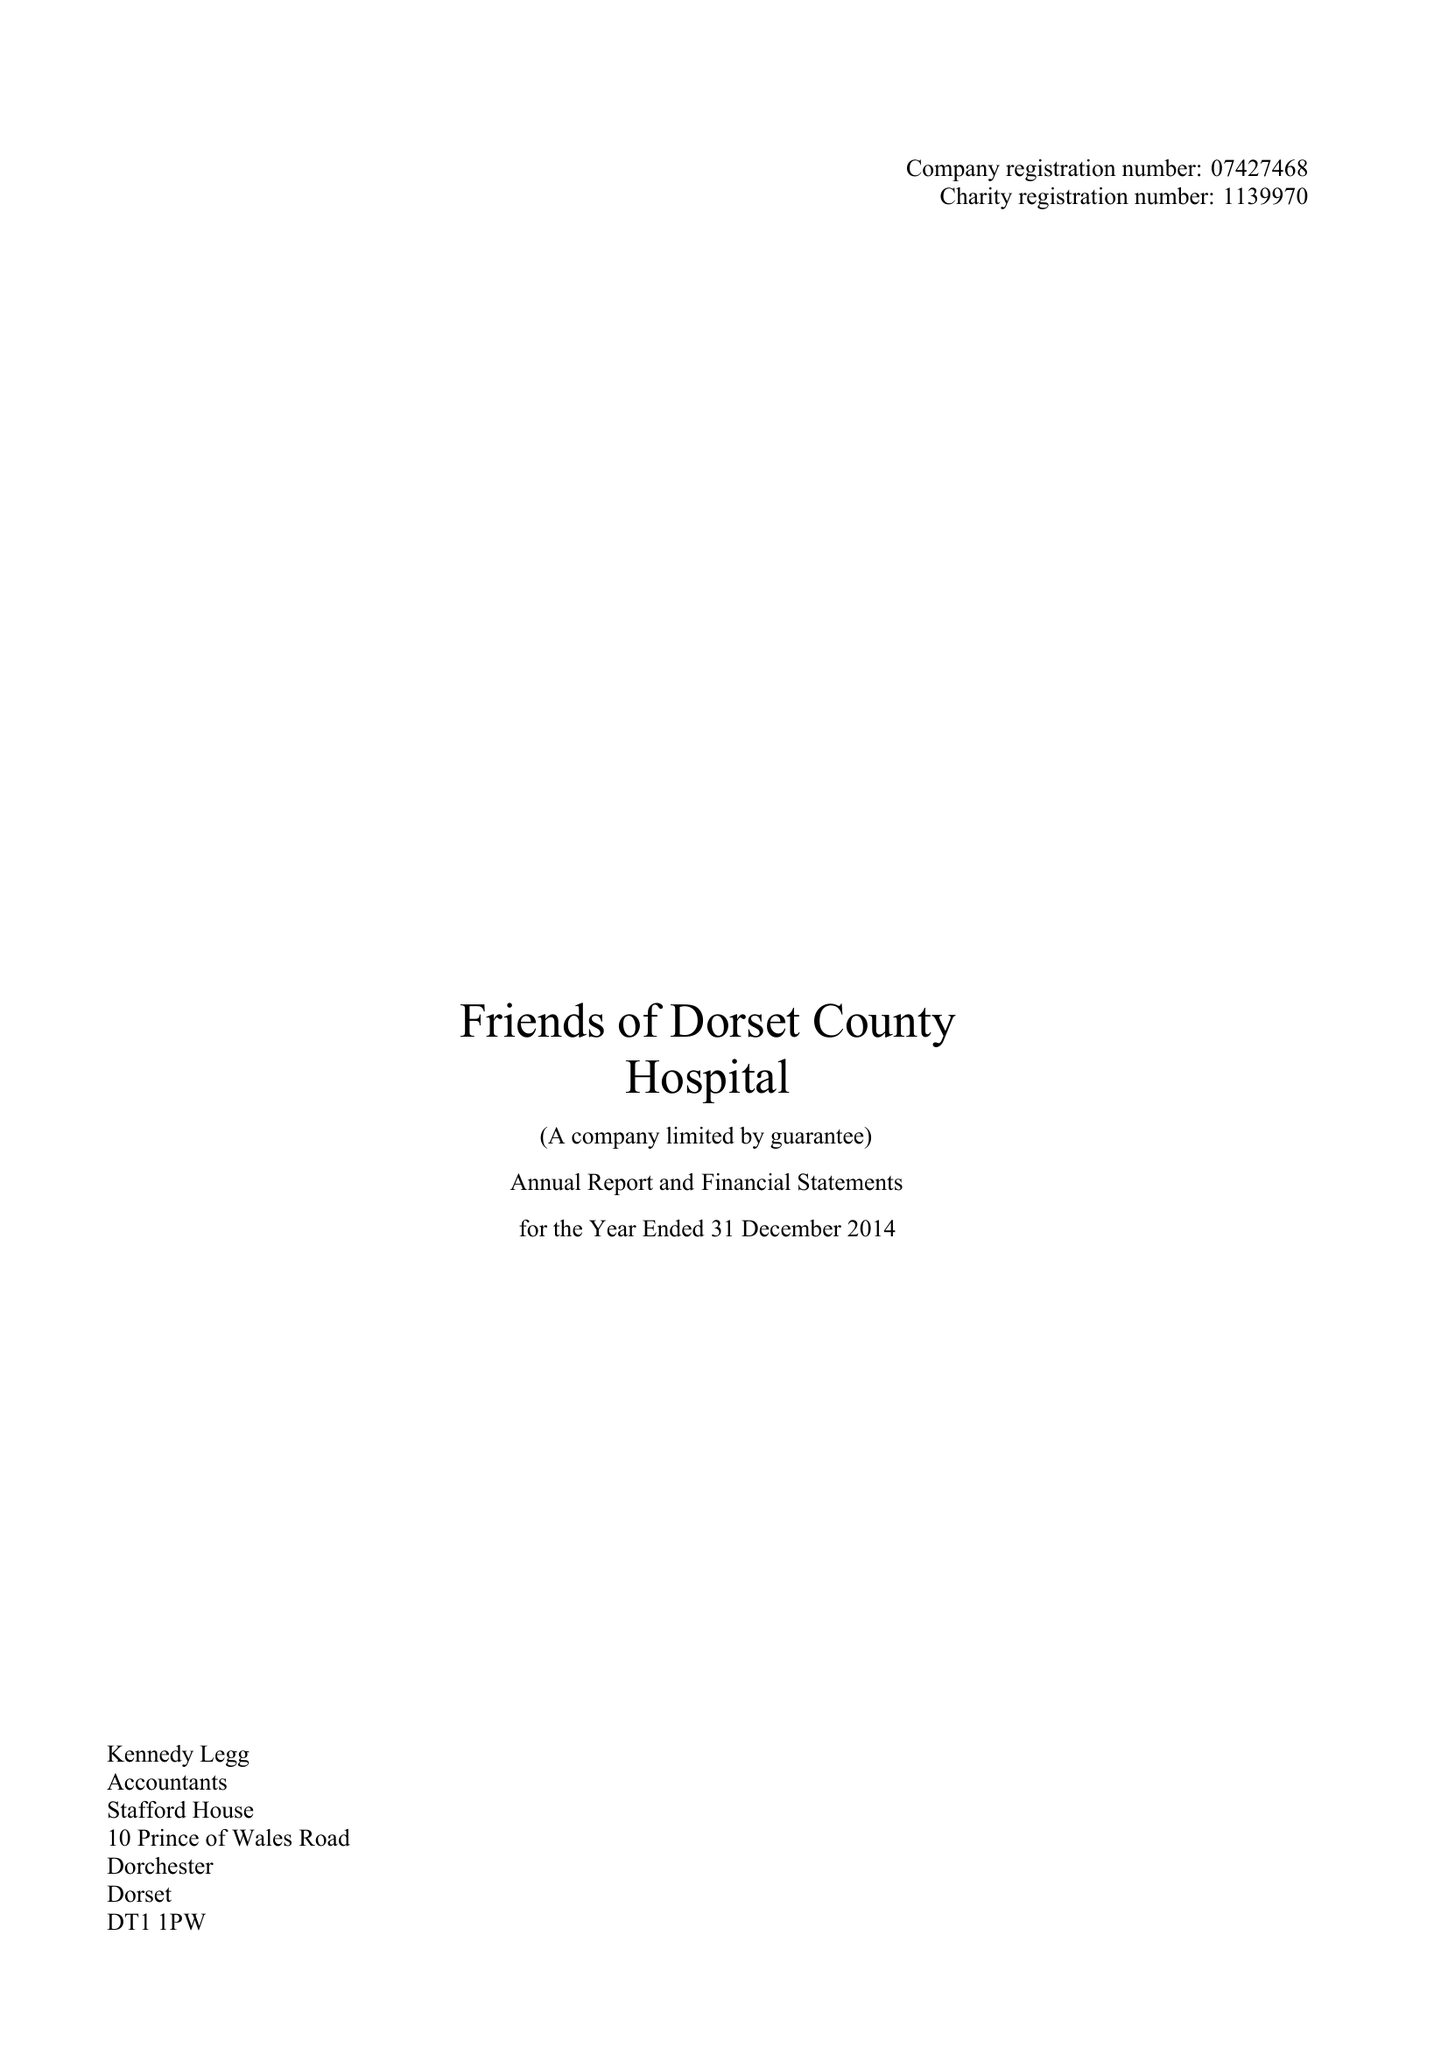What is the value for the address__street_line?
Answer the question using a single word or phrase. PRINCE OF WALES ROAD 